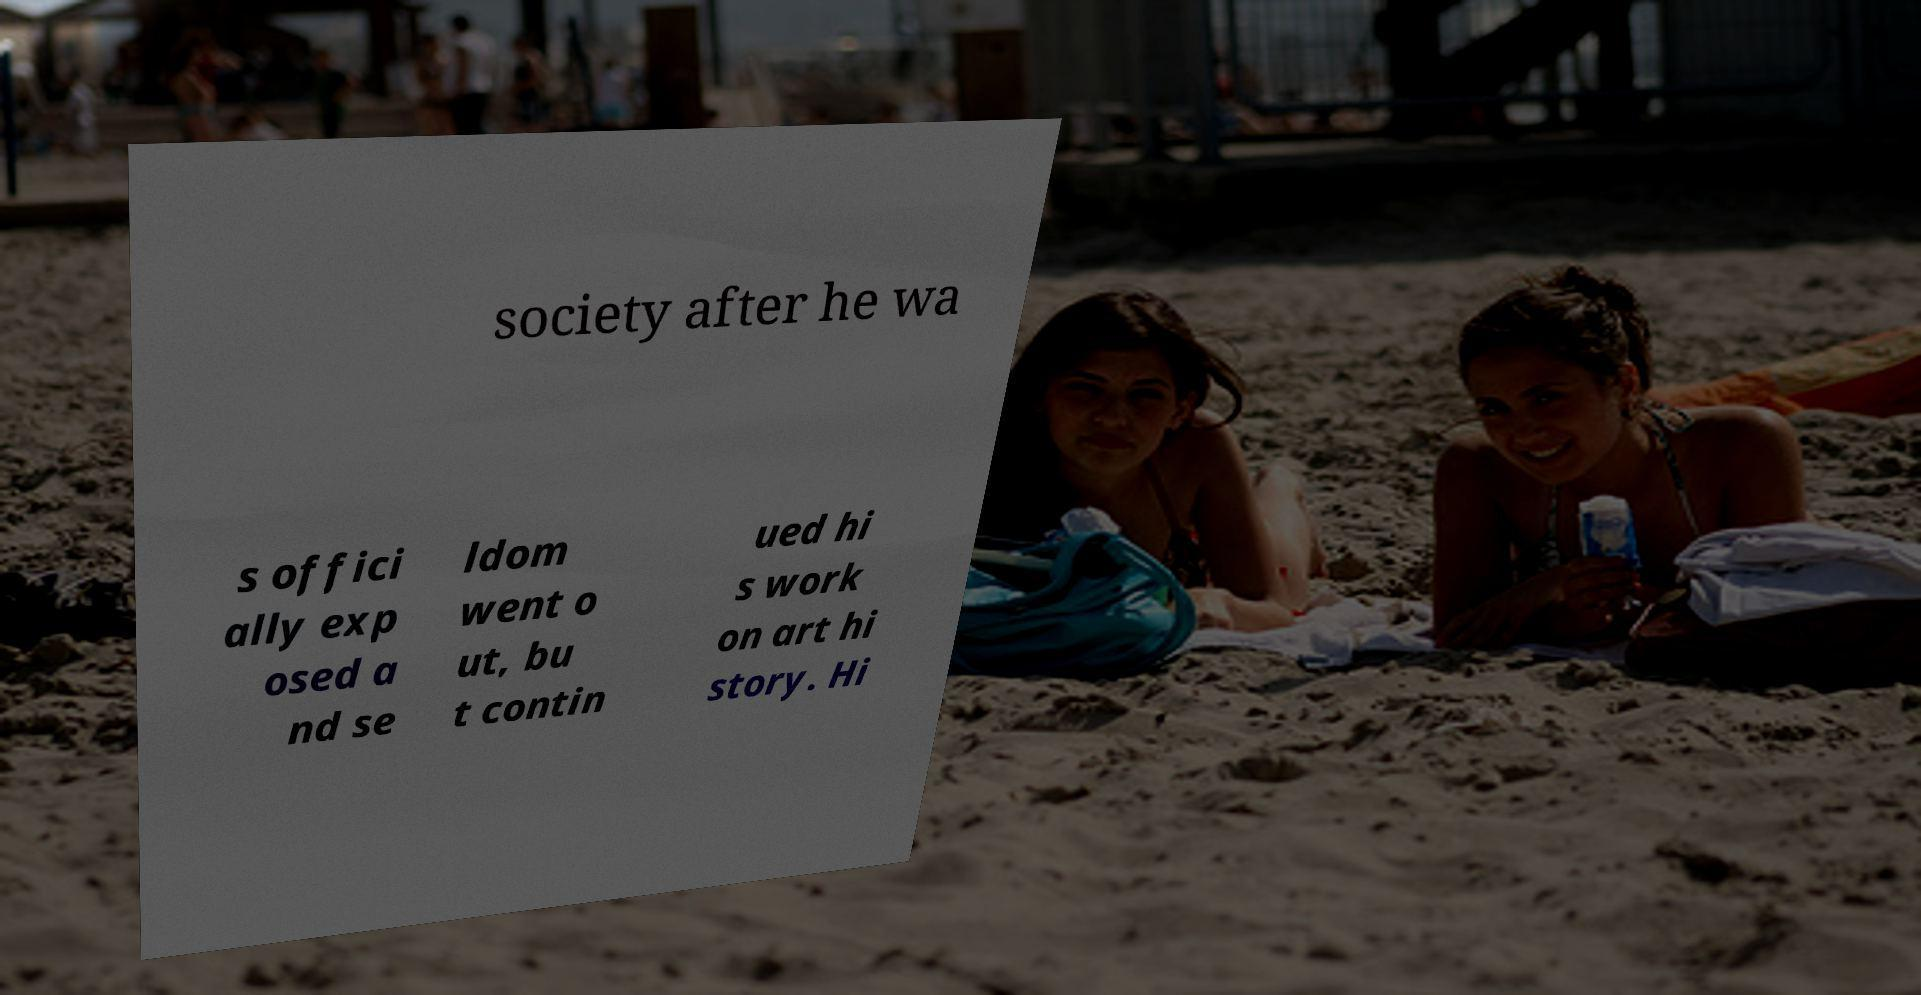There's text embedded in this image that I need extracted. Can you transcribe it verbatim? society after he wa s offici ally exp osed a nd se ldom went o ut, bu t contin ued hi s work on art hi story. Hi 